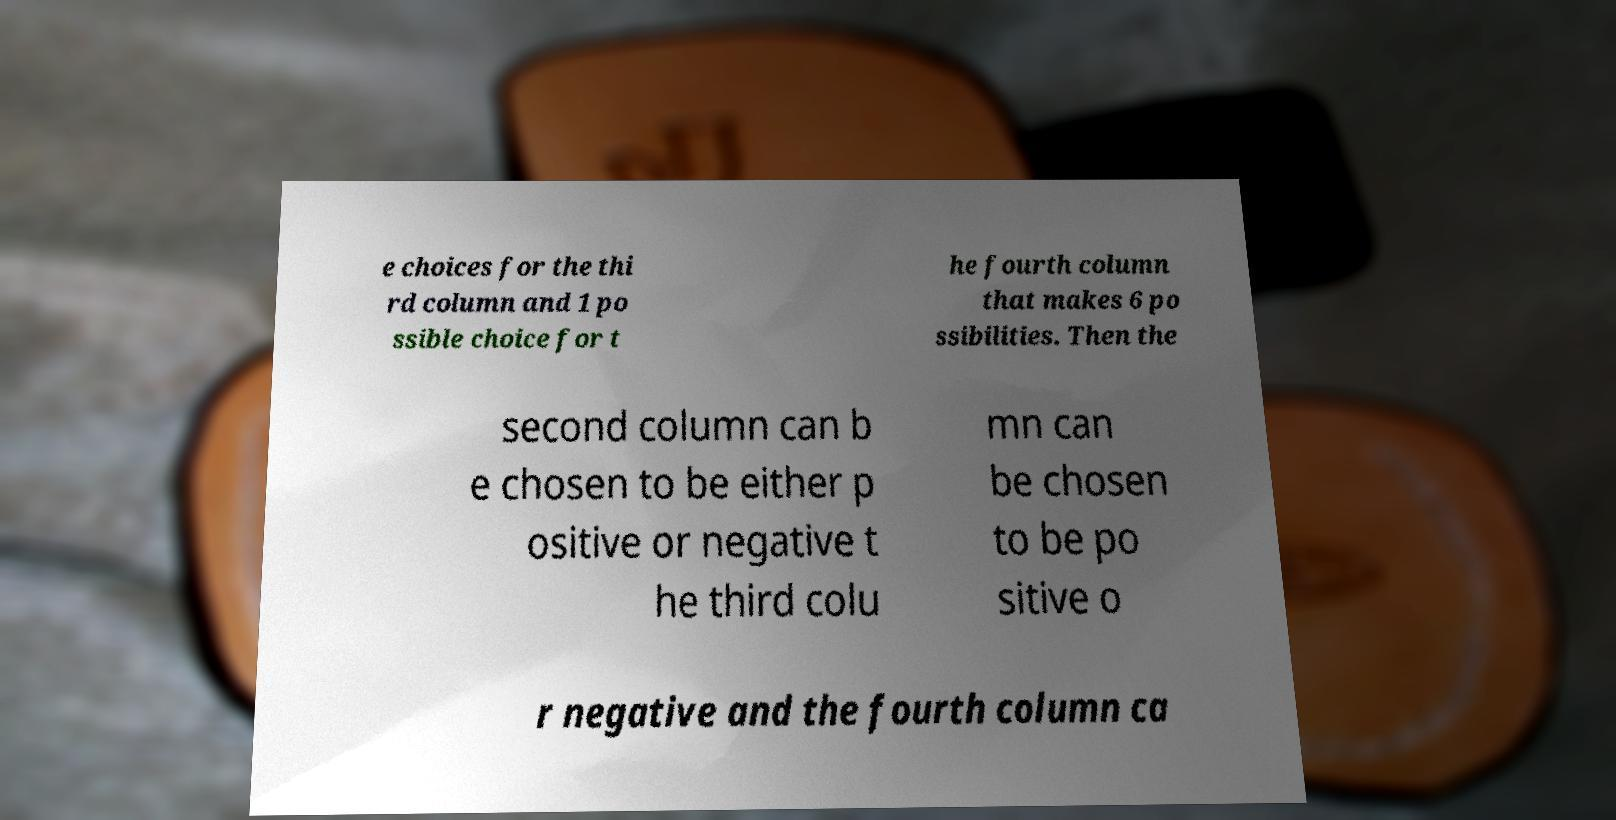I need the written content from this picture converted into text. Can you do that? e choices for the thi rd column and 1 po ssible choice for t he fourth column that makes 6 po ssibilities. Then the second column can b e chosen to be either p ositive or negative t he third colu mn can be chosen to be po sitive o r negative and the fourth column ca 